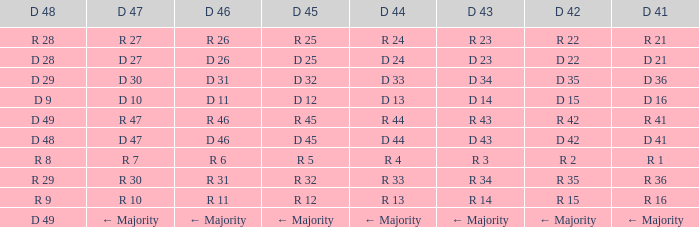Name the D 48 when it has a D 44 of d 33 D 29. 